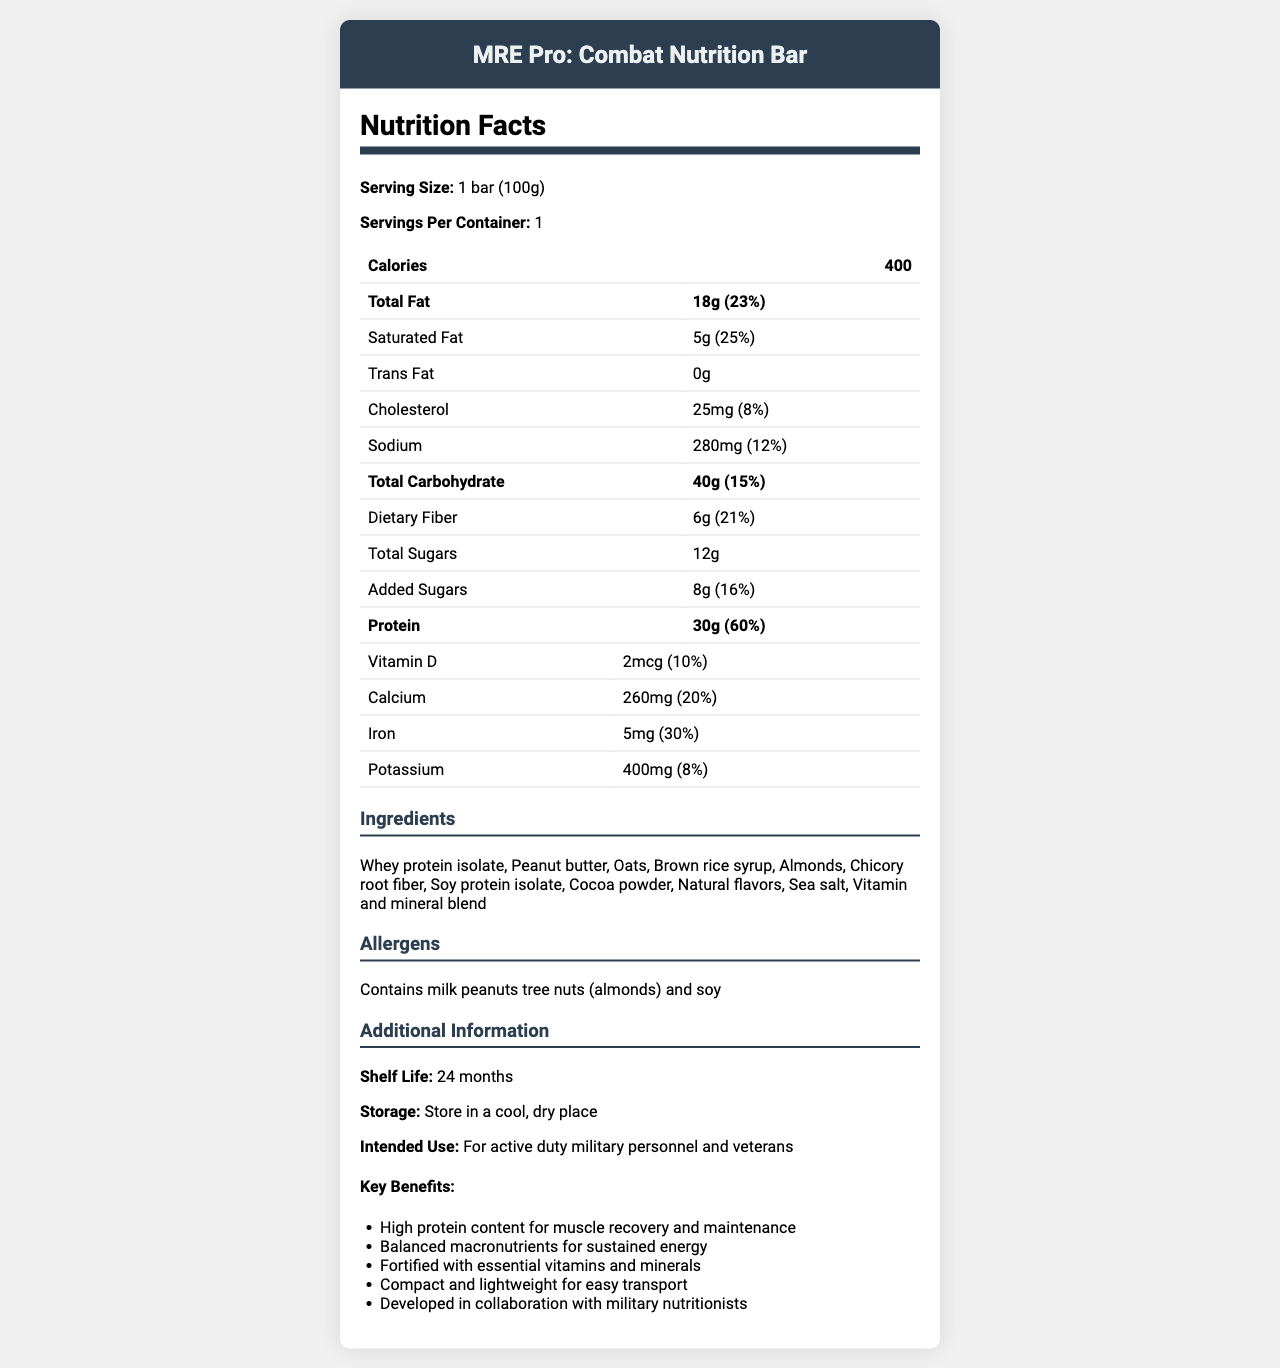What is the serving size of the MRE Pro: Combat Nutrition Bar? The serving size is clearly stated in the document under the section for Nutrition Facts as "1 bar (100g)".
Answer: 1 bar (100g) How much dietary fiber is in one serving? According to the Nutrition Facts section, one serving of the bar contains 6g of dietary fiber.
Answer: 6g What is the percentage of the daily value for total fat in this product? The document indicates that the total fat content provides 23% of the daily value.
Answer: 23% List all the allergens present in the MRE Pro: Combat Nutrition Bar. The document explicitly lists the allergens under the Allergens section.
Answer: Contains milk, peanuts, tree nuts (almonds), and soy How much protein does each bar contain? The amount of protein per serving is listed in the Nutrition Facts section as 30g.
Answer: 30g Which vitamin is present in the highest quantity as a percentage of the daily value? 
A. Vitamin D 
B. Vitamin C 
C. Iron 
D. Vitamin B6 Iron has the highest percentage of the daily value at 30%, according to the Nutrition Facts.
Answer: C What are the primary benefits of the MRE Pro: Combat Nutrition Bar? 
A. Low in calories and minerals 
B. High in protein and fiber 
C. Low fat and low carb 
D. High in saturated fats and sugars The key benefits section mentions "High protein content for muscle recovery and maintenance" and "Balanced macronutrients for sustained energy," indicating the bar is high in protein and fiber.
Answer: B Does this bar contain any trans fat? The Nutrition Facts specify that the trans fat content is 0g.
Answer: No Summarize the main idea of the document. The document provides detailed nutritional information, ingredients, allergens, additional information about shelf life, storage, intended use, and key benefits of the product.
Answer: The MRE Pro: Combat Nutrition Bar is a high-protein, nutritionally balanced meal replacement bar designed for active duty military personnel and veterans, containing various essential vitamins and minerals, and is easy to transport and store. How many grams of total sugars are there in the bar? The total sugars content is listed as 12g in the Nutrition Facts.
Answer: 12g Is the MRE Pro: Combat Nutrition Bar suitable for vegans? The document does not provide enough information regarding the source of all ingredients, although it mentions allergens like milk.
Answer: Cannot be determined How much calcium is in one serving? According to the Nutrition Facts section, each serving contains 260mg of calcium.
Answer: 260mg What is the shelf life of the MRE Pro: Combat Nutrition Bar? The Additional Information section states that the shelf life is 24 months.
Answer: 24 months Which ingredient is listed first in the ingredients section? The Ingredients section lists "Whey protein isolate" first.
Answer: Whey protein isolate 